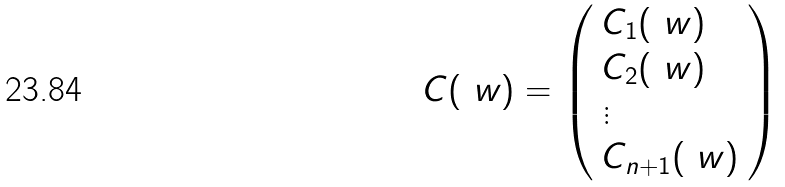<formula> <loc_0><loc_0><loc_500><loc_500>C ( \ w ) = \left ( \begin{array} { l l } C _ { 1 } ( \ w ) \\ C _ { 2 } ( \ w ) \\ \vdots \\ C _ { n + 1 } ( \ w ) \end{array} \right )</formula> 